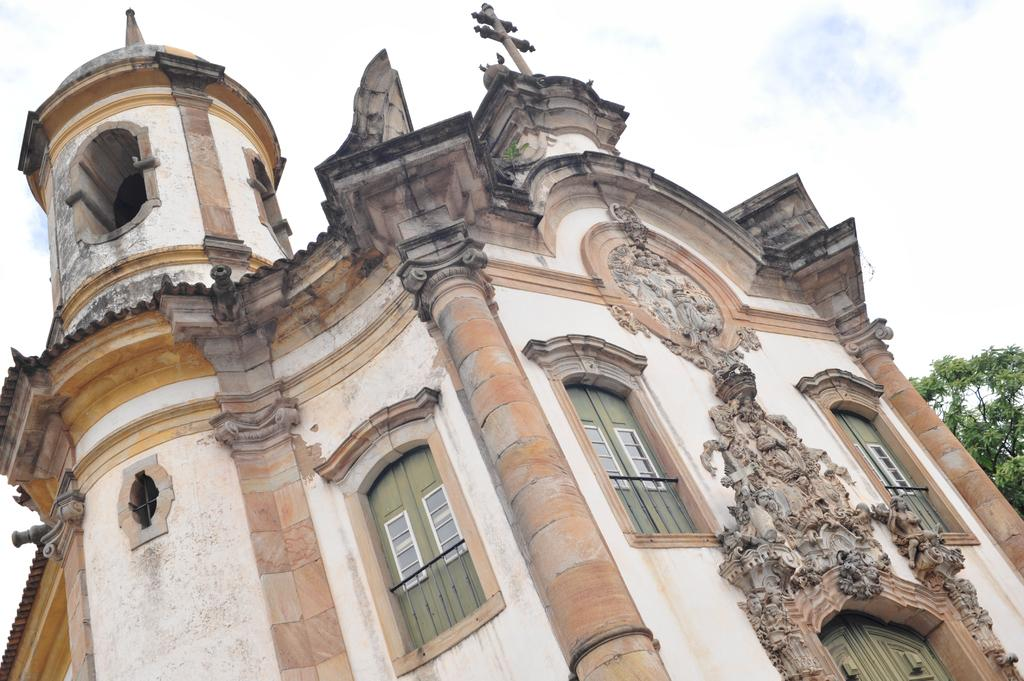What type of structure is present in the picture? There is a building in the picture. What other natural element can be seen in the picture? There is a tree in the picture. What decorative features are present on the building? There are stone carvings on the wall of the building. How would you describe the weather in the picture? The sky is cloudy in the picture. What type of test can be seen on the tree in the picture? There is no test present in the picture; it features a building, a tree, stone carvings, and a cloudy sky. What type of receipt is visible on the wall of the building? There is no receipt present in the picture; it features a building, a tree, stone carvings, and a cloudy sky. 